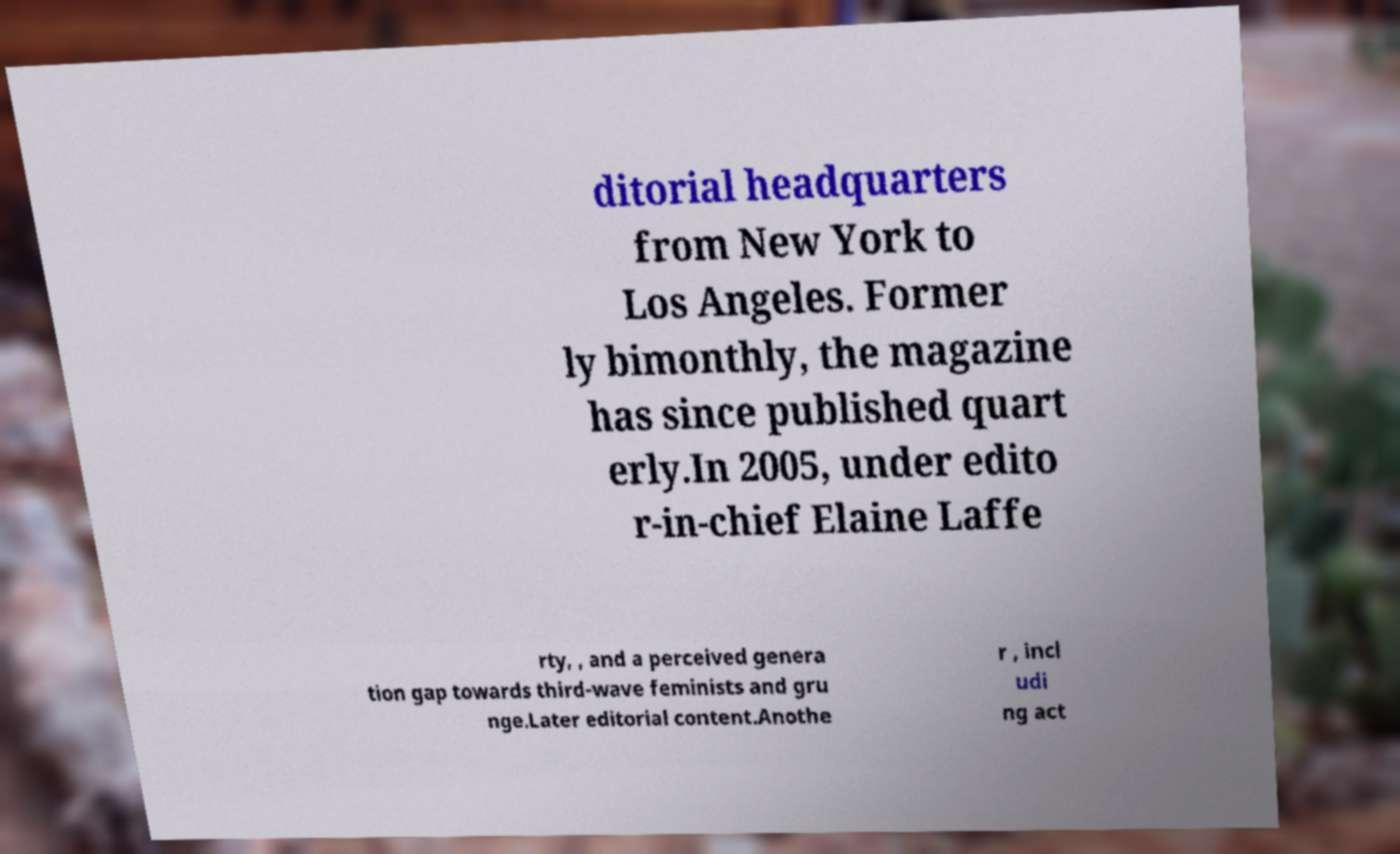Please identify and transcribe the text found in this image. ditorial headquarters from New York to Los Angeles. Former ly bimonthly, the magazine has since published quart erly.In 2005, under edito r-in-chief Elaine Laffe rty, , and a perceived genera tion gap towards third-wave feminists and gru nge.Later editorial content.Anothe r , incl udi ng act 